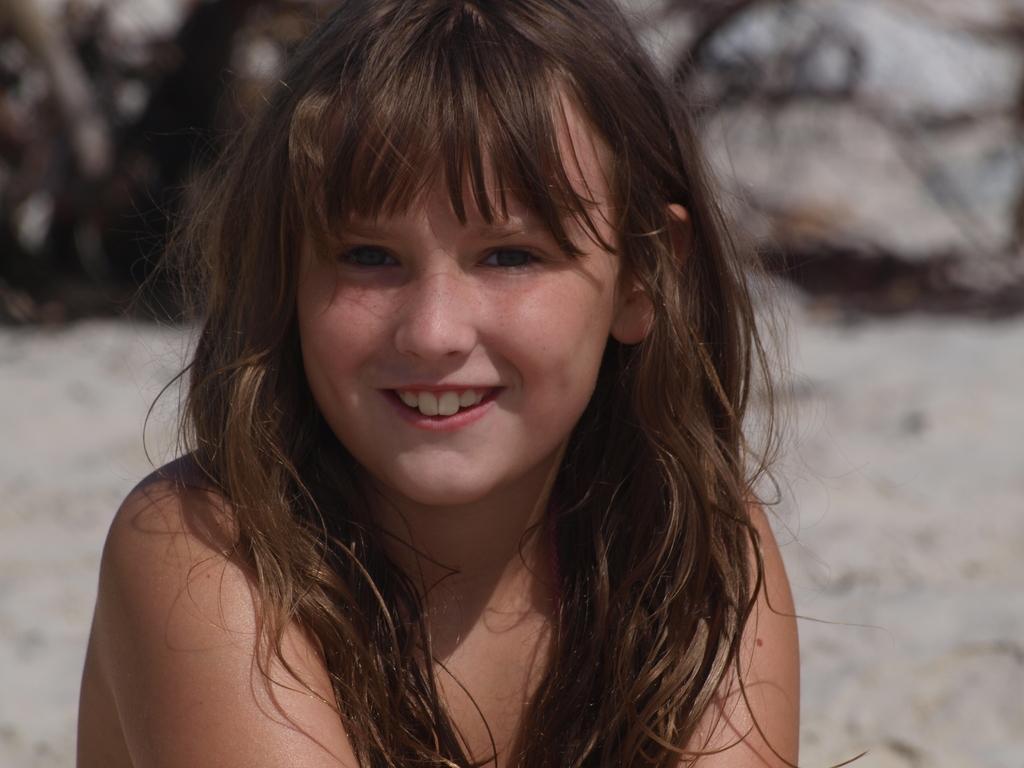In one or two sentences, can you explain what this image depicts? As we can see in the image in the front there is a woman and in the background there are rocks and the background is little blurred. 